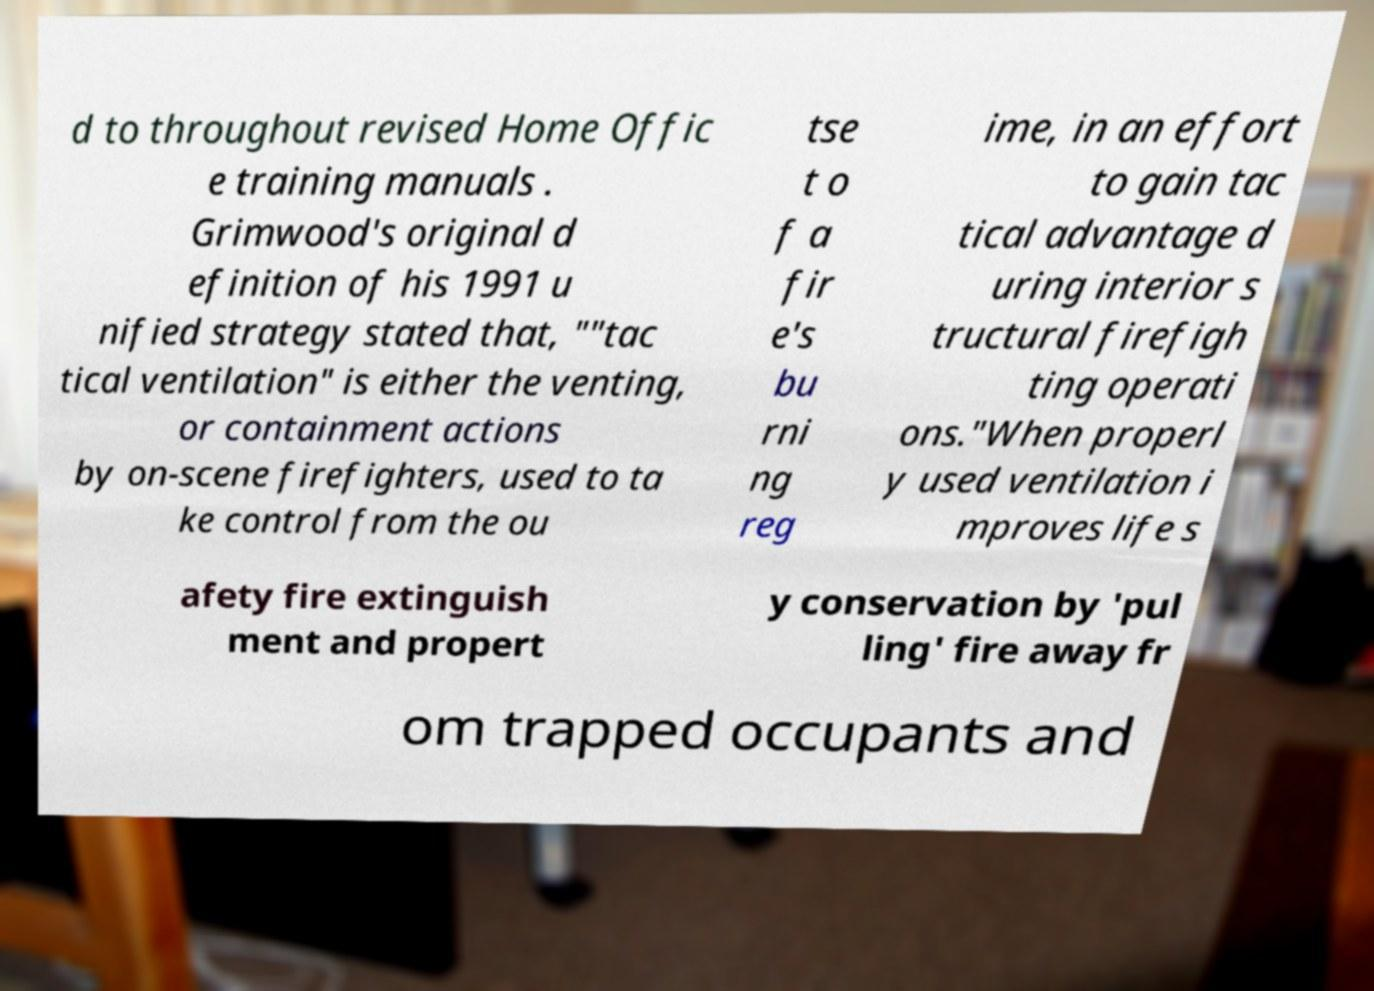Could you assist in decoding the text presented in this image and type it out clearly? d to throughout revised Home Offic e training manuals . Grimwood's original d efinition of his 1991 u nified strategy stated that, ""tac tical ventilation" is either the venting, or containment actions by on-scene firefighters, used to ta ke control from the ou tse t o f a fir e's bu rni ng reg ime, in an effort to gain tac tical advantage d uring interior s tructural firefigh ting operati ons."When properl y used ventilation i mproves life s afety fire extinguish ment and propert y conservation by 'pul ling' fire away fr om trapped occupants and 